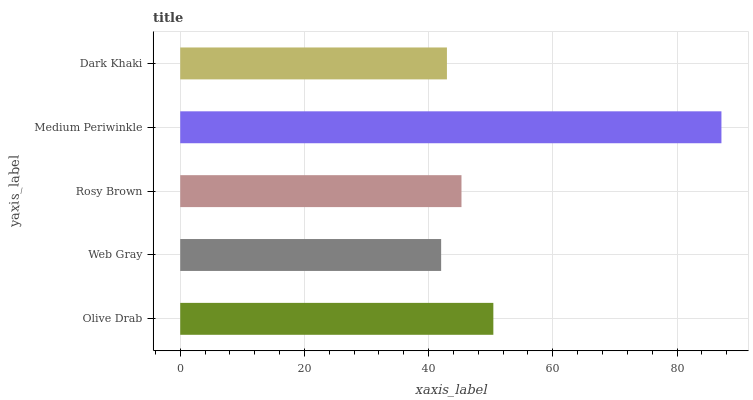Is Web Gray the minimum?
Answer yes or no. Yes. Is Medium Periwinkle the maximum?
Answer yes or no. Yes. Is Rosy Brown the minimum?
Answer yes or no. No. Is Rosy Brown the maximum?
Answer yes or no. No. Is Rosy Brown greater than Web Gray?
Answer yes or no. Yes. Is Web Gray less than Rosy Brown?
Answer yes or no. Yes. Is Web Gray greater than Rosy Brown?
Answer yes or no. No. Is Rosy Brown less than Web Gray?
Answer yes or no. No. Is Rosy Brown the high median?
Answer yes or no. Yes. Is Rosy Brown the low median?
Answer yes or no. Yes. Is Dark Khaki the high median?
Answer yes or no. No. Is Dark Khaki the low median?
Answer yes or no. No. 